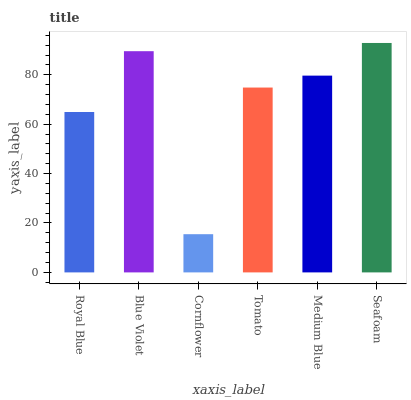Is Cornflower the minimum?
Answer yes or no. Yes. Is Seafoam the maximum?
Answer yes or no. Yes. Is Blue Violet the minimum?
Answer yes or no. No. Is Blue Violet the maximum?
Answer yes or no. No. Is Blue Violet greater than Royal Blue?
Answer yes or no. Yes. Is Royal Blue less than Blue Violet?
Answer yes or no. Yes. Is Royal Blue greater than Blue Violet?
Answer yes or no. No. Is Blue Violet less than Royal Blue?
Answer yes or no. No. Is Medium Blue the high median?
Answer yes or no. Yes. Is Tomato the low median?
Answer yes or no. Yes. Is Royal Blue the high median?
Answer yes or no. No. Is Blue Violet the low median?
Answer yes or no. No. 